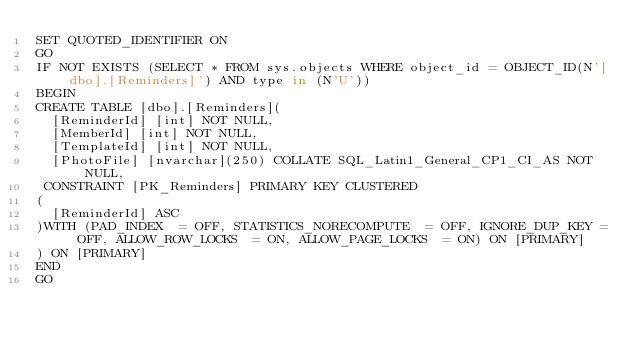Convert code to text. <code><loc_0><loc_0><loc_500><loc_500><_SQL_>SET QUOTED_IDENTIFIER ON
GO
IF NOT EXISTS (SELECT * FROM sys.objects WHERE object_id = OBJECT_ID(N'[dbo].[Reminders]') AND type in (N'U'))
BEGIN
CREATE TABLE [dbo].[Reminders](
	[ReminderId] [int] NOT NULL,
	[MemberId] [int] NOT NULL,
	[TemplateId] [int] NOT NULL,
	[PhotoFile] [nvarchar](250) COLLATE SQL_Latin1_General_CP1_CI_AS NOT NULL,
 CONSTRAINT [PK_Reminders] PRIMARY KEY CLUSTERED 
(
	[ReminderId] ASC
)WITH (PAD_INDEX  = OFF, STATISTICS_NORECOMPUTE  = OFF, IGNORE_DUP_KEY = OFF, ALLOW_ROW_LOCKS  = ON, ALLOW_PAGE_LOCKS  = ON) ON [PRIMARY]
) ON [PRIMARY]
END
GO
</code> 